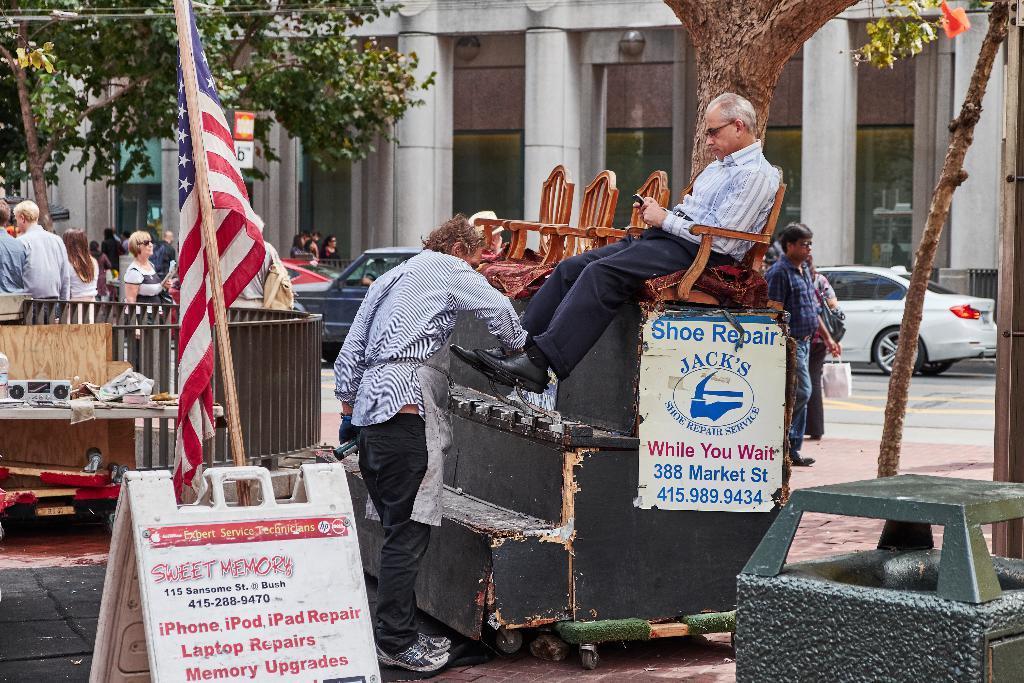Could you give a brief overview of what you see in this image? This is an outside view. In the middle of the image I can see a man sitting on a bench, holding the mobile in the hands and looking at the mobile. In front of this man another man is standing and polishing his shoes. In the foreground, I can see a dustbin and a board to which a flag is attached and on the board I can see some text. On the left side there is a railing. In the background I can see few cars and people on the road. In the background there is a building and trees. 